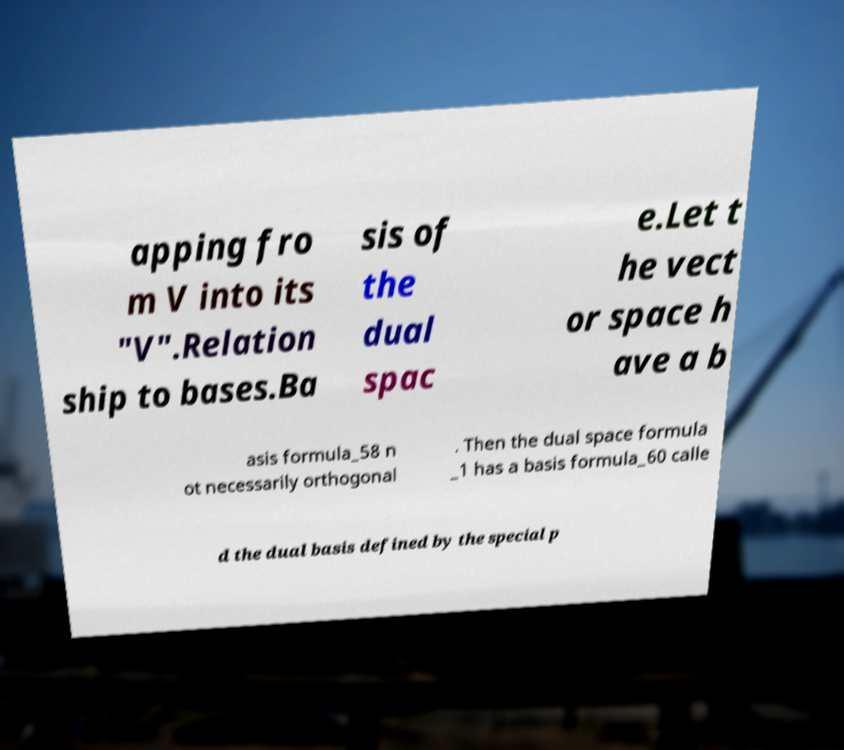Please read and relay the text visible in this image. What does it say? apping fro m V into its "V".Relation ship to bases.Ba sis of the dual spac e.Let t he vect or space h ave a b asis formula_58 n ot necessarily orthogonal . Then the dual space formula _1 has a basis formula_60 calle d the dual basis defined by the special p 